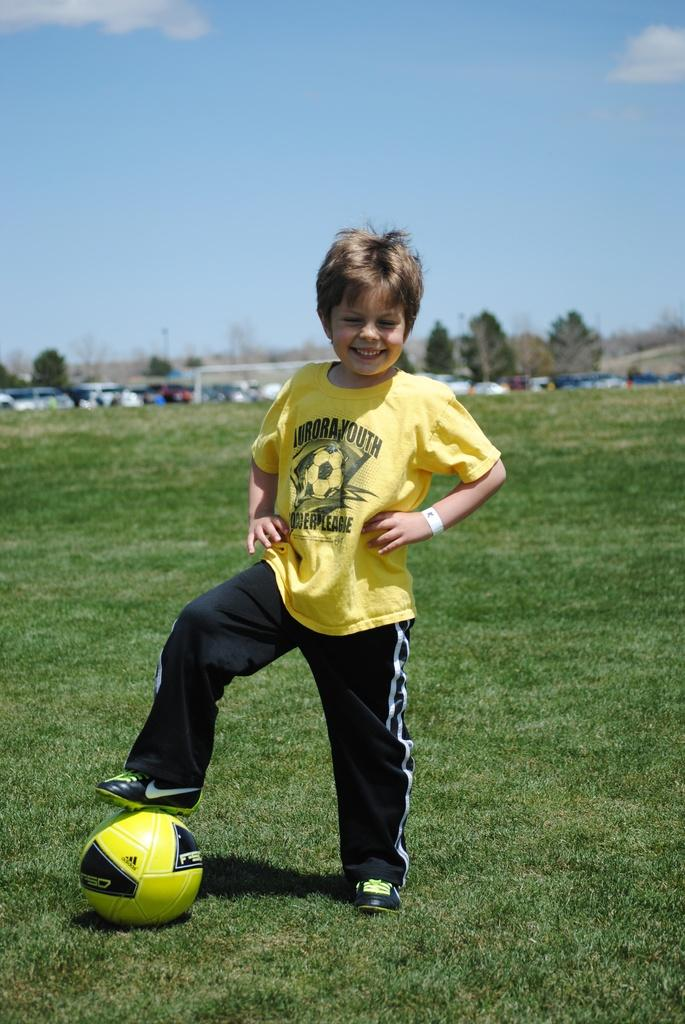<image>
Give a short and clear explanation of the subsequent image. Boy wearing a shirt which says "AURORA YOUTH" is posing with a soccer ball. 